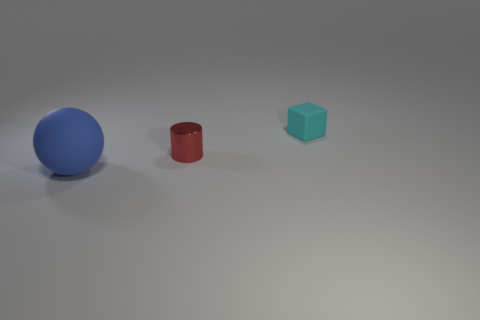Is there any other thing that has the same size as the ball?
Give a very brief answer. No. How many other objects are there of the same material as the large object?
Provide a succinct answer. 1. Do the tiny object behind the red thing and the large blue sphere have the same material?
Your response must be concise. Yes. Is the number of rubber spheres that are to the left of the small cylinder greater than the number of large blue spheres that are behind the block?
Ensure brevity in your answer.  Yes. What number of things are either things that are behind the small red shiny cylinder or small things?
Provide a succinct answer. 2. There is a thing that is made of the same material as the small cyan cube; what is its shape?
Make the answer very short. Sphere. Are there any other things that have the same shape as the blue object?
Your response must be concise. No. The object that is both to the right of the large blue rubber ball and to the left of the tiny cyan thing is what color?
Your answer should be very brief. Red. How many cylinders are either purple rubber objects or red things?
Offer a very short reply. 1. How many blue rubber objects are the same size as the sphere?
Offer a very short reply. 0. 